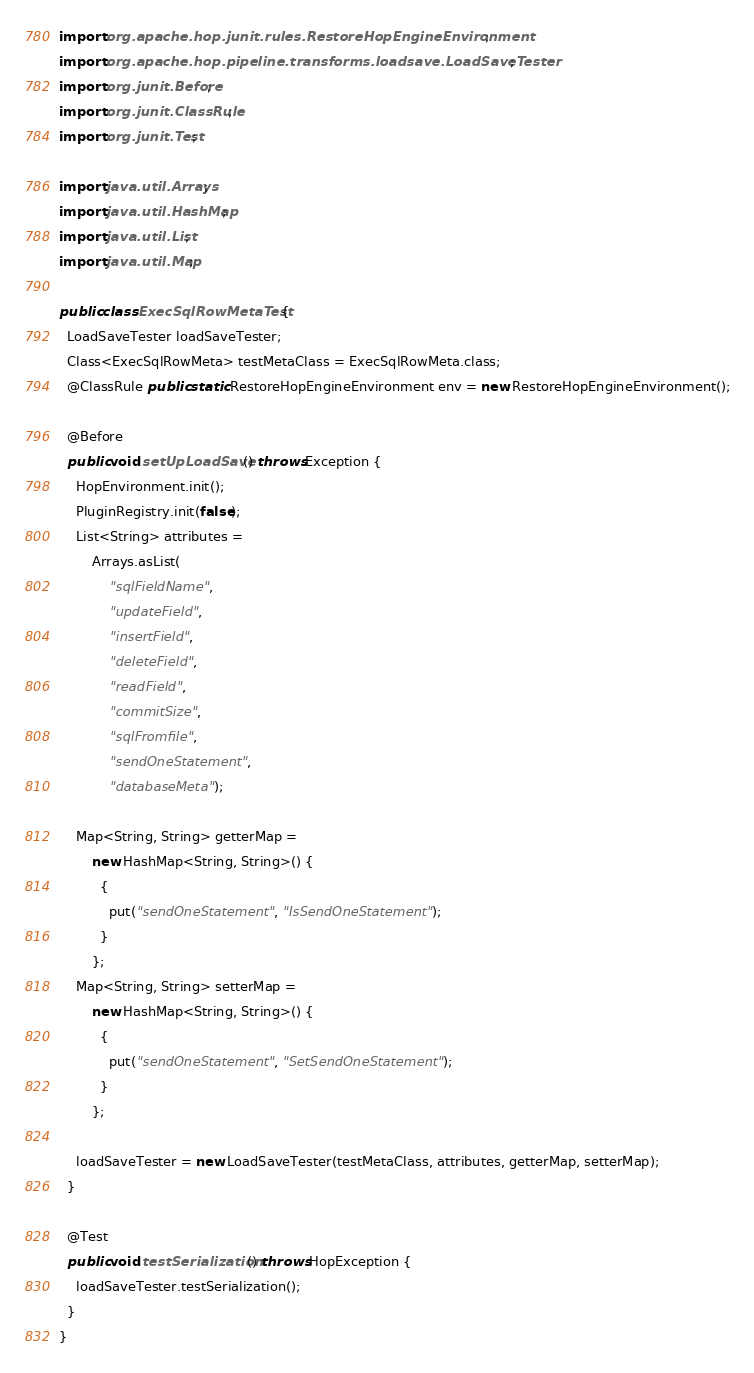<code> <loc_0><loc_0><loc_500><loc_500><_Java_>import org.apache.hop.junit.rules.RestoreHopEngineEnvironment;
import org.apache.hop.pipeline.transforms.loadsave.LoadSaveTester;
import org.junit.Before;
import org.junit.ClassRule;
import org.junit.Test;

import java.util.Arrays;
import java.util.HashMap;
import java.util.List;
import java.util.Map;

public class ExecSqlRowMetaTest {
  LoadSaveTester loadSaveTester;
  Class<ExecSqlRowMeta> testMetaClass = ExecSqlRowMeta.class;
  @ClassRule public static RestoreHopEngineEnvironment env = new RestoreHopEngineEnvironment();

  @Before
  public void setUpLoadSave() throws Exception {
    HopEnvironment.init();
    PluginRegistry.init(false);
    List<String> attributes =
        Arrays.asList(
            "sqlFieldName",
            "updateField",
            "insertField",
            "deleteField",
            "readField",
            "commitSize",
            "sqlFromfile",
            "sendOneStatement",
            "databaseMeta");

    Map<String, String> getterMap =
        new HashMap<String, String>() {
          {
            put("sendOneStatement", "IsSendOneStatement");
          }
        };
    Map<String, String> setterMap =
        new HashMap<String, String>() {
          {
            put("sendOneStatement", "SetSendOneStatement");
          }
        };

    loadSaveTester = new LoadSaveTester(testMetaClass, attributes, getterMap, setterMap);
  }

  @Test
  public void testSerialization() throws HopException {
    loadSaveTester.testSerialization();
  }
}
</code> 